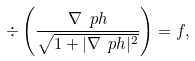Convert formula to latex. <formula><loc_0><loc_0><loc_500><loc_500>\div \left ( \frac { \nabla \ p h } { \sqrt { 1 + | \nabla \ p h | ^ { 2 } } } \right ) = f ,</formula> 